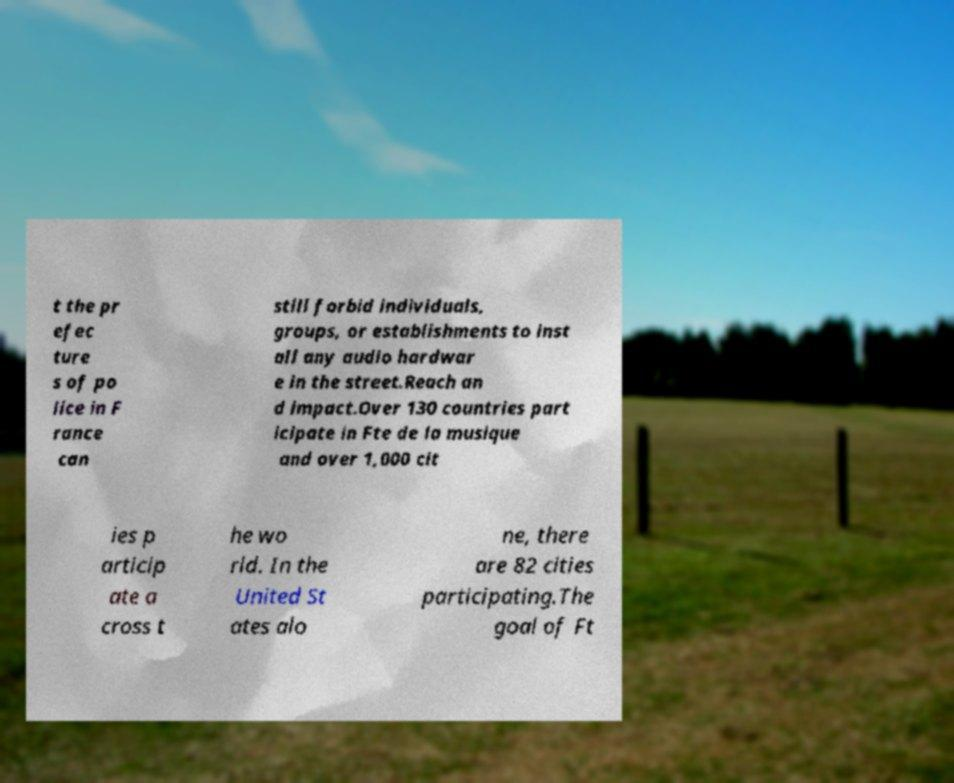Could you assist in decoding the text presented in this image and type it out clearly? t the pr efec ture s of po lice in F rance can still forbid individuals, groups, or establishments to inst all any audio hardwar e in the street.Reach an d impact.Over 130 countries part icipate in Fte de la musique and over 1,000 cit ies p articip ate a cross t he wo rld. In the United St ates alo ne, there are 82 cities participating.The goal of Ft 